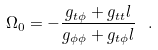Convert formula to latex. <formula><loc_0><loc_0><loc_500><loc_500>\Omega _ { 0 } = - \frac { g _ { t \phi } + g _ { t t } l } { g _ { \phi \phi } + g _ { t \phi } l } \ .</formula> 